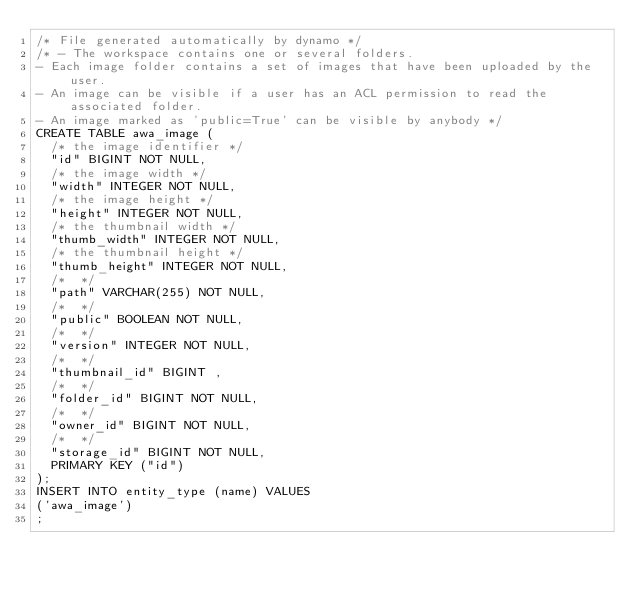<code> <loc_0><loc_0><loc_500><loc_500><_SQL_>/* File generated automatically by dynamo */
/* - The workspace contains one or several folders.
- Each image folder contains a set of images that have been uploaded by the user.
- An image can be visible if a user has an ACL permission to read the associated folder.
- An image marked as 'public=True' can be visible by anybody */
CREATE TABLE awa_image (
  /* the image identifier */
  "id" BIGINT NOT NULL,
  /* the image width */
  "width" INTEGER NOT NULL,
  /* the image height */
  "height" INTEGER NOT NULL,
  /* the thumbnail width */
  "thumb_width" INTEGER NOT NULL,
  /* the thumbnail height */
  "thumb_height" INTEGER NOT NULL,
  /*  */
  "path" VARCHAR(255) NOT NULL,
  /*  */
  "public" BOOLEAN NOT NULL,
  /*  */
  "version" INTEGER NOT NULL,
  /*  */
  "thumbnail_id" BIGINT ,
  /*  */
  "folder_id" BIGINT NOT NULL,
  /*  */
  "owner_id" BIGINT NOT NULL,
  /*  */
  "storage_id" BIGINT NOT NULL,
  PRIMARY KEY ("id")
);
INSERT INTO entity_type (name) VALUES
('awa_image')
;
</code> 